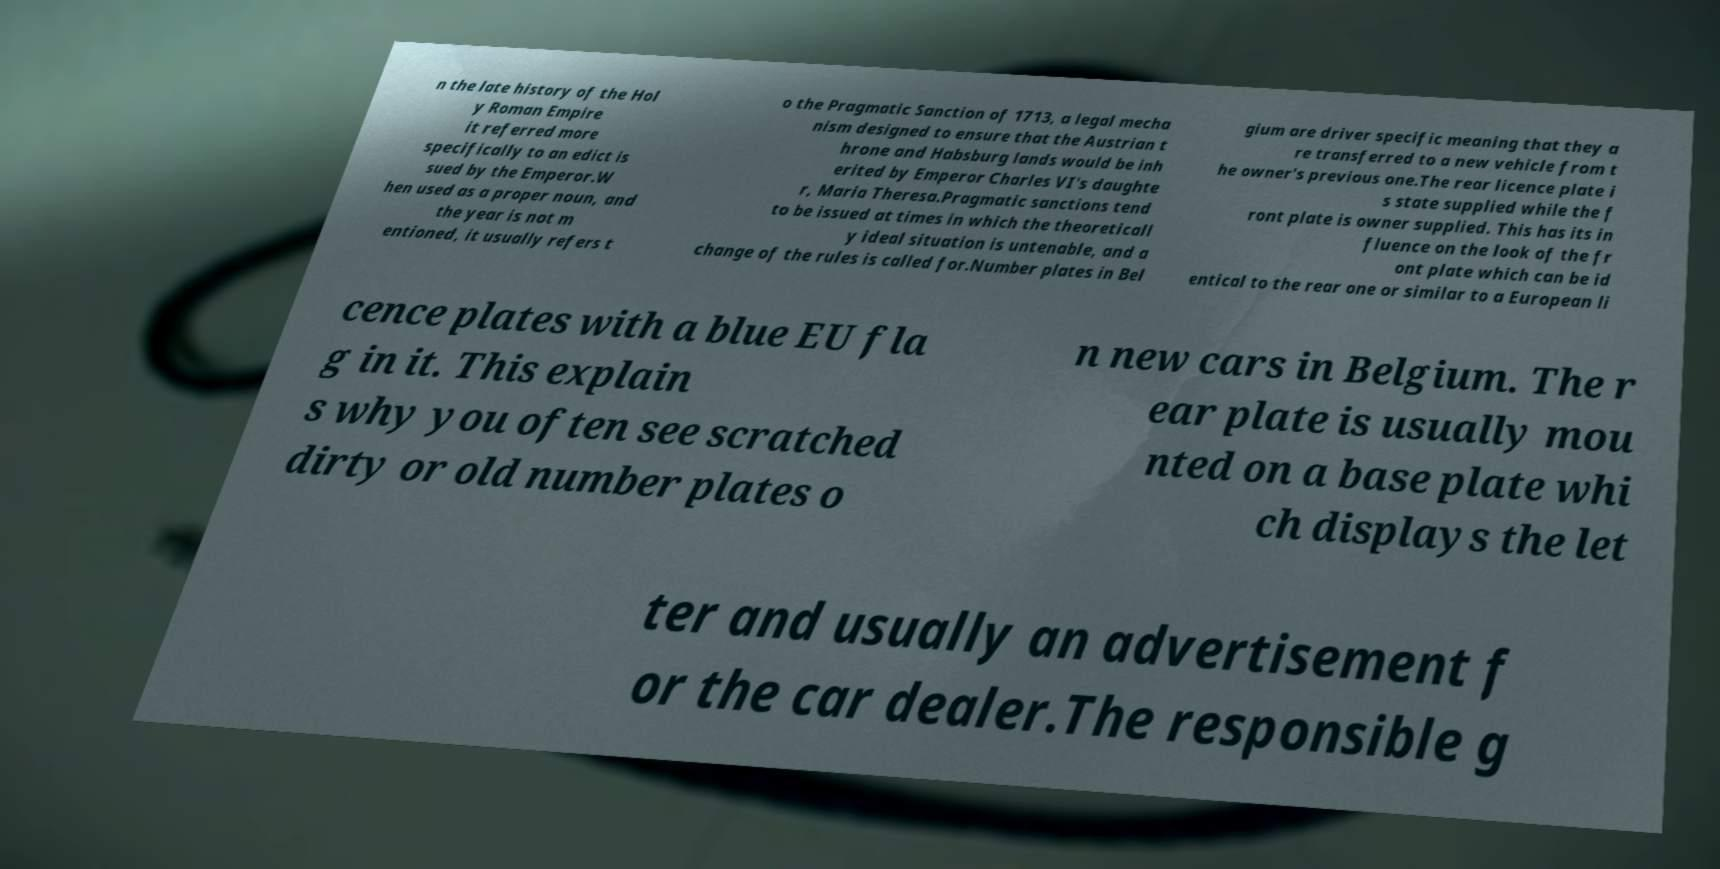Please identify and transcribe the text found in this image. n the late history of the Hol y Roman Empire it referred more specifically to an edict is sued by the Emperor.W hen used as a proper noun, and the year is not m entioned, it usually refers t o the Pragmatic Sanction of 1713, a legal mecha nism designed to ensure that the Austrian t hrone and Habsburg lands would be inh erited by Emperor Charles VI's daughte r, Maria Theresa.Pragmatic sanctions tend to be issued at times in which the theoreticall y ideal situation is untenable, and a change of the rules is called for.Number plates in Bel gium are driver specific meaning that they a re transferred to a new vehicle from t he owner's previous one.The rear licence plate i s state supplied while the f ront plate is owner supplied. This has its in fluence on the look of the fr ont plate which can be id entical to the rear one or similar to a European li cence plates with a blue EU fla g in it. This explain s why you often see scratched dirty or old number plates o n new cars in Belgium. The r ear plate is usually mou nted on a base plate whi ch displays the let ter and usually an advertisement f or the car dealer.The responsible g 